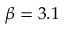<formula> <loc_0><loc_0><loc_500><loc_500>\beta = 3 . 1</formula> 